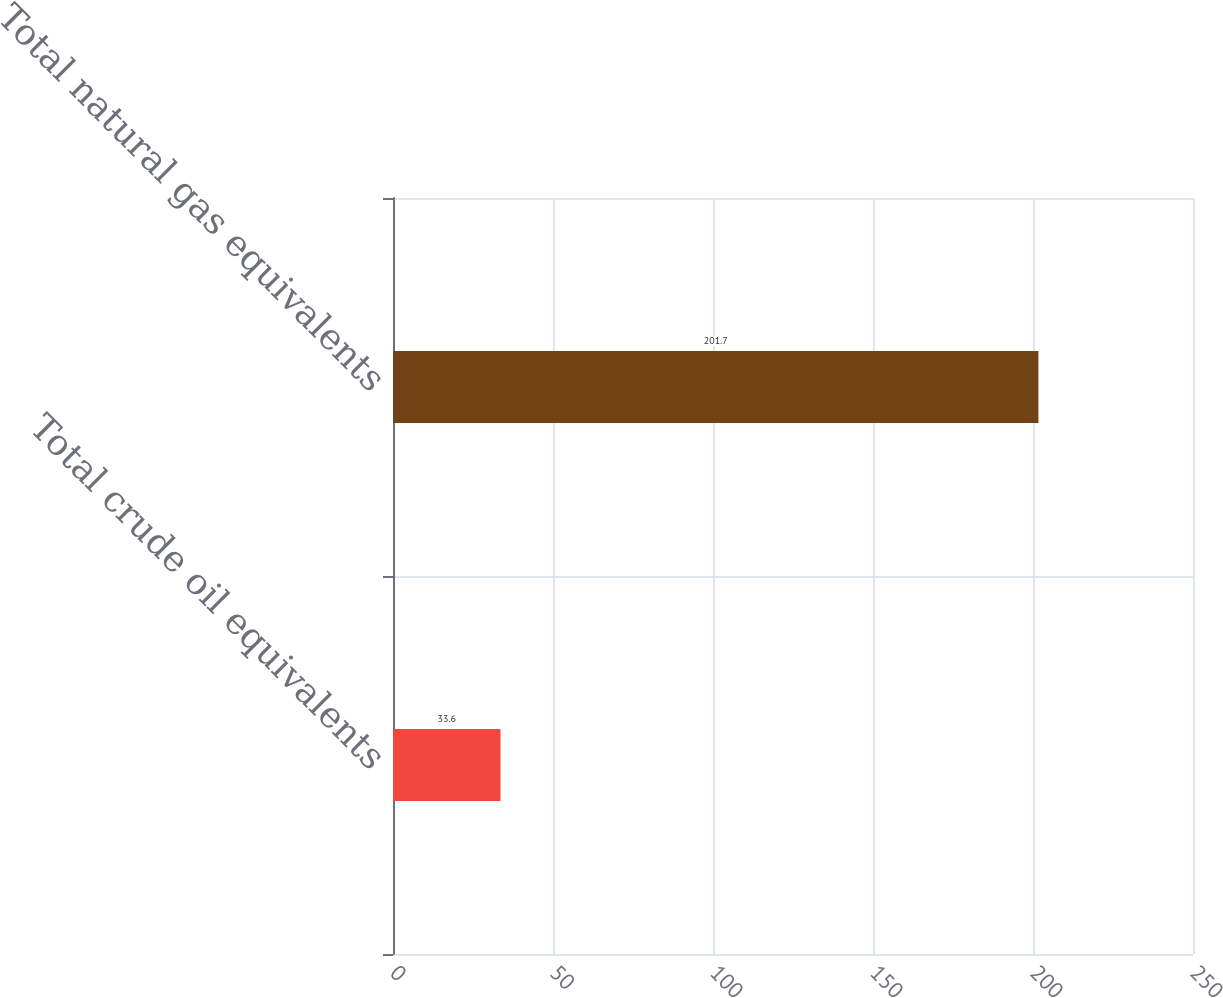<chart> <loc_0><loc_0><loc_500><loc_500><bar_chart><fcel>Total crude oil equivalents<fcel>Total natural gas equivalents<nl><fcel>33.6<fcel>201.7<nl></chart> 